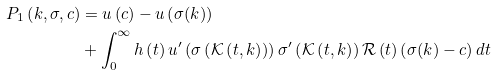Convert formula to latex. <formula><loc_0><loc_0><loc_500><loc_500>P _ { 1 } \left ( k , \sigma , c \right ) & = u \left ( c \right ) - u \left ( \sigma ( k ) \right ) \\ & + \int _ { 0 } ^ { \infty } h \left ( t \right ) u ^ { \prime } \left ( \sigma \left ( \mathcal { K } \left ( t , k \right ) \right ) \right ) \sigma ^ { \prime } \left ( \mathcal { K } \left ( t , k \right ) \right ) \mathcal { R } \left ( t \right ) \left ( \sigma ( k ) - c \right ) d t</formula> 